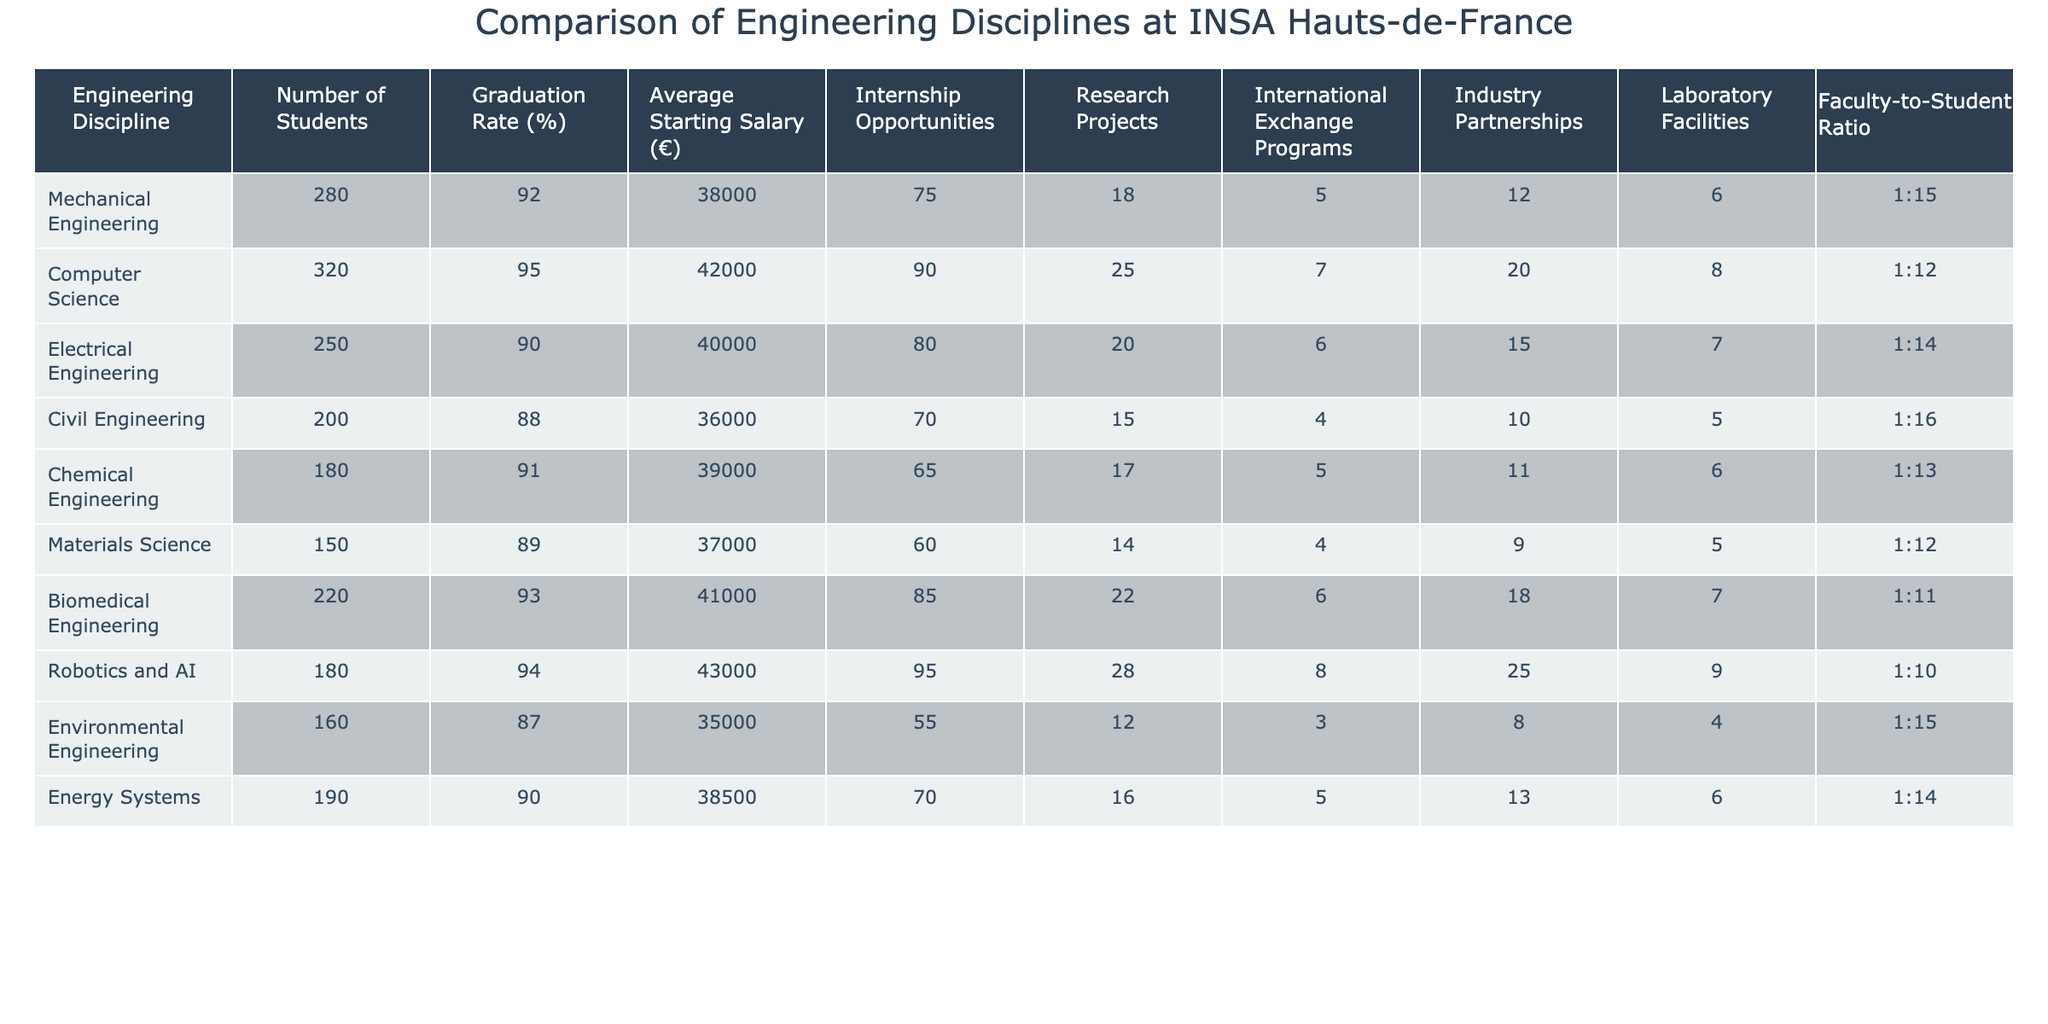What is the average starting salary for students in Biomedical Engineering? The table shows that the average starting salary for Biomedical Engineering is €41,000.
Answer: €41,000 Which engineering discipline has the highest graduation rate? By comparing the graduation rates, Computer Science has the highest graduation rate at 95%.
Answer: 95% How many engineering disciplines have a faculty-to-student ratio of 1:14 or better? The disciplines with a ratio of 1:14 or better are Computer Science, Chemical Engineering, Electrical Engineering, and Energy Systems, which makes it a total of 4 disciplines.
Answer: 4 Is the average starting salary for Mechanical Engineering higher than that for Civil Engineering? The average starting salary for Mechanical Engineering is €38,000, while for Civil Engineering it is €36,000, thus confirming that it is higher.
Answer: Yes What is the total number of students across all engineering disciplines? By adding up the number of students in each discipline: (280 + 320 + 250 + 200 + 180 + 150 + 220 + 180 + 160 + 190) = 1,830, leading to a total of 1,830 students.
Answer: 1,830 Which engineering discipline has the least number of internship opportunities? The discipline with the least internship opportunities is Environmental Engineering, offering only 55 opportunities.
Answer: 55 If you average the graduation rates of Mechanical and Electrical Engineering, what do you get? The average of the graduation rates is calculated as (92% + 90%) / 2 = 91%.
Answer: 91% Considering industry partnerships, what discipline has the most? By examining the table, Robotics and AI has the most industry partnerships with 25.
Answer: 25 Is Chemical Engineering better than Materials Science in terms of graduation rate? The graduation rate for Chemical Engineering is 91%, while for Materials Science it is 89%, making Chemical Engineering better in this aspect.
Answer: Yes How does the faculty-to-student ratio of Biomedical Engineering compare to that of Civil Engineering? The ratio for Biomedical Engineering is 1:11 while for Civil Engineering it is 1:16, indicating Biomedical Engineering has a more favorable ratio.
Answer: More favorable What is the difference in average starting salaries between Computer Science and Environmental Engineering? The difference is calculated as €42,000 (Computer Science) - €35,000 (Environmental Engineering) = €7,000.
Answer: €7,000 